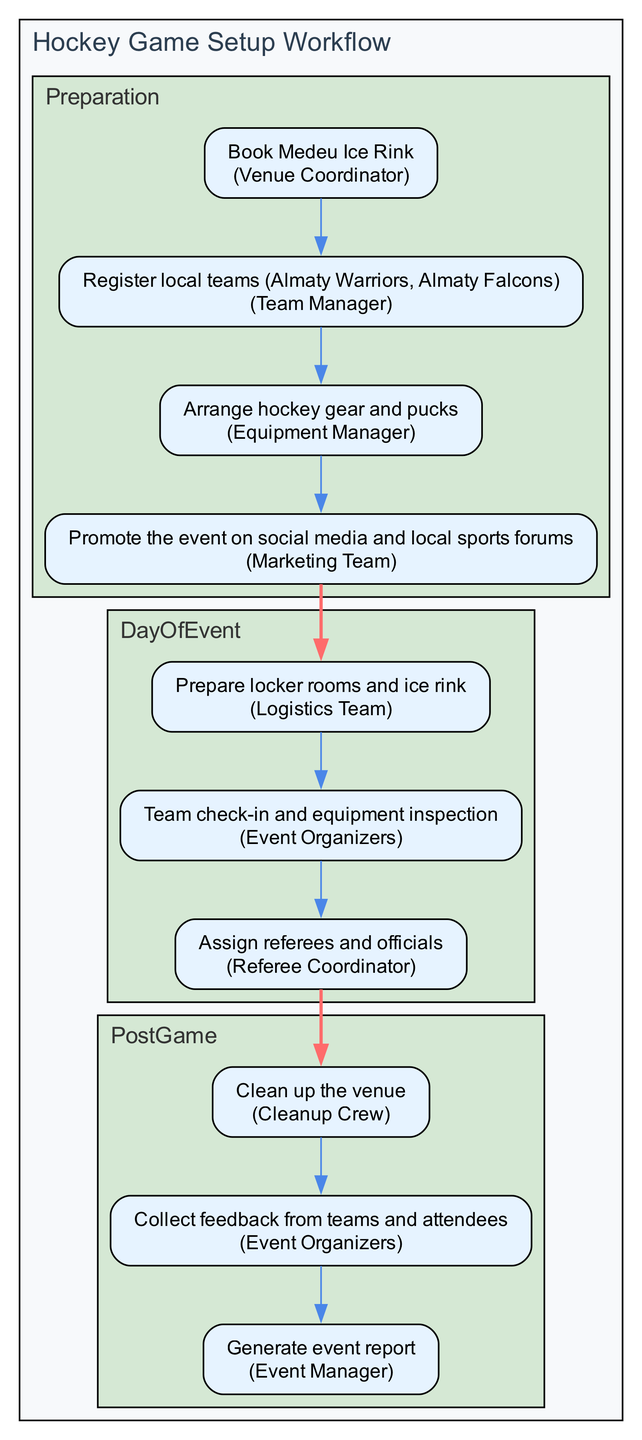What is the first task in the Preparation phase? The first task in the Preparation phase, as indicated in the diagram, is "Book Medeu Ice Rink." This task is assigned to the Venue Coordinator.
Answer: Book Medeu Ice Rink How many tasks are there in the Day of Event phase? The Day of Event phase contains three tasks: Setup, Check-In, and Game Referees. Therefore, the total number of tasks is three.
Answer: 3 Who is responsible for cleaning up after the game? According to the diagram, the responsible party for cleaning up the venue post-game is the Cleanup Crew.
Answer: Cleanup Crew What task comes immediately after Team Registration? The task that comes immediately after Team Registration is "Arrange hockey gear and pucks." This can be determined by following the order of tasks listed within the Preparation phase.
Answer: Arrange hockey gear and pucks Which team is responsible for promoting the event? The Marketing Team is responsible for promoting the event as per the diagram's indication under the Advertising task in the Preparation phase.
Answer: Marketing Team What is the last task in the Post Game phase? The last task in the Post Game phase is "Generate event report," and this task is assigned to the Event Manager. This can be verified by checking the sequence of tasks outlined in the phase.
Answer: Generate event report How many total phases are represented in the diagram? The diagram includes three phases: Preparation, Day of Event, and Post Game. Counting each one provides the total number of phases.
Answer: 3 Who is tasked with equipment inspection on the day of the event? The task of team check-in and equipment inspection on the day of the event falls under the responsibility of the Event Organizers, as described in the Check-In node.
Answer: Event Organizers 